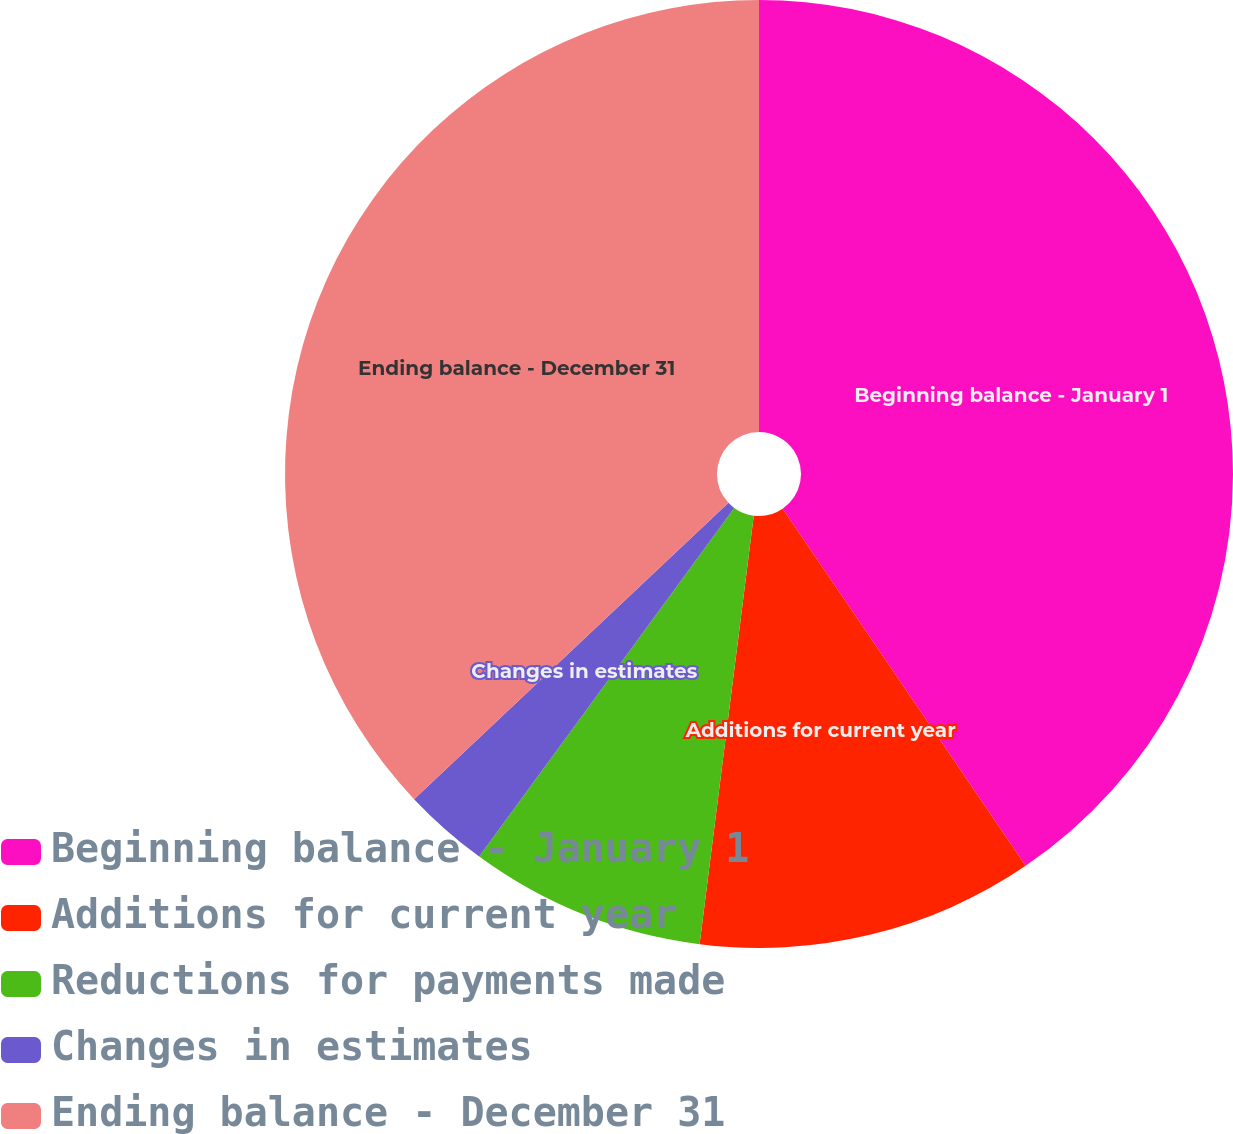Convert chart. <chart><loc_0><loc_0><loc_500><loc_500><pie_chart><fcel>Beginning balance - January 1<fcel>Additions for current year<fcel>Reductions for payments made<fcel>Changes in estimates<fcel>Ending balance - December 31<nl><fcel>40.49%<fcel>11.51%<fcel>8.05%<fcel>2.92%<fcel>37.03%<nl></chart> 